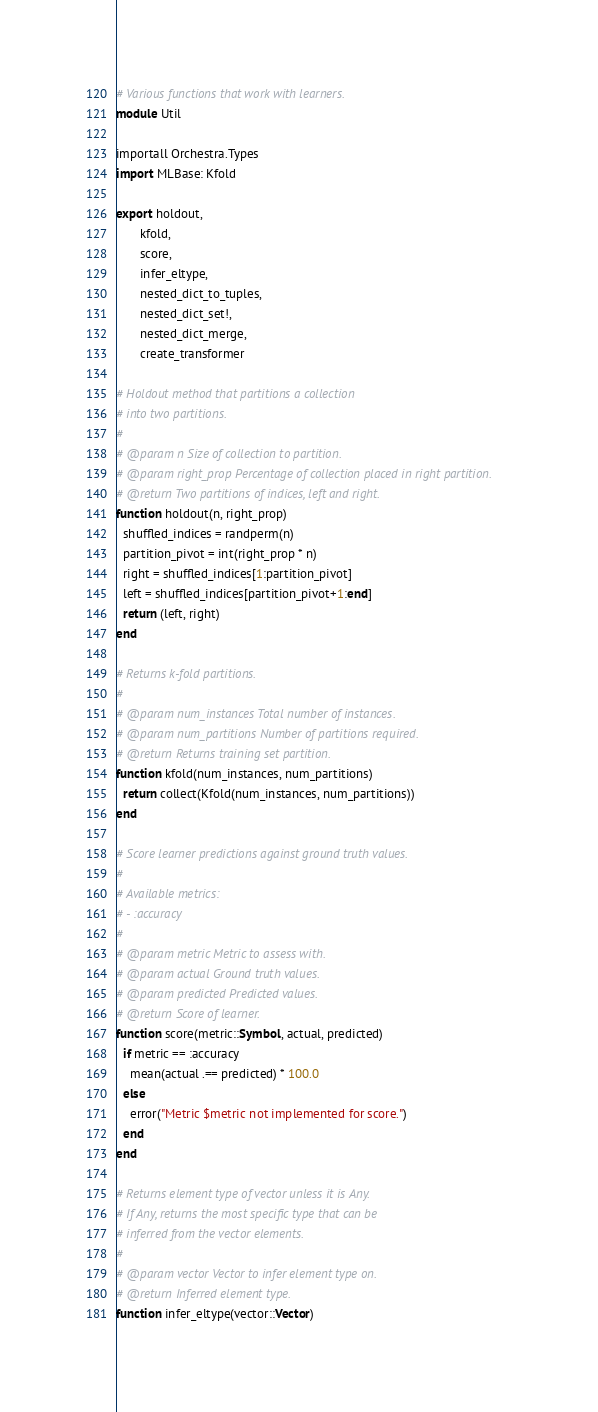<code> <loc_0><loc_0><loc_500><loc_500><_Julia_># Various functions that work with learners.
module Util

importall Orchestra.Types
import MLBase: Kfold

export holdout,
       kfold,
       score,
       infer_eltype,
       nested_dict_to_tuples,
       nested_dict_set!,
       nested_dict_merge,
       create_transformer

# Holdout method that partitions a collection
# into two partitions.
#
# @param n Size of collection to partition.
# @param right_prop Percentage of collection placed in right partition.
# @return Two partitions of indices, left and right.
function holdout(n, right_prop)
  shuffled_indices = randperm(n)
  partition_pivot = int(right_prop * n)
  right = shuffled_indices[1:partition_pivot]
  left = shuffled_indices[partition_pivot+1:end]
  return (left, right)
end

# Returns k-fold partitions.
#
# @param num_instances Total number of instances.
# @param num_partitions Number of partitions required.
# @return Returns training set partition.
function kfold(num_instances, num_partitions)
  return collect(Kfold(num_instances, num_partitions))
end

# Score learner predictions against ground truth values.
#
# Available metrics:
# - :accuracy
#
# @param metric Metric to assess with.
# @param actual Ground truth values.
# @param predicted Predicted values.
# @return Score of learner.
function score(metric::Symbol, actual, predicted)
  if metric == :accuracy
    mean(actual .== predicted) * 100.0
  else
    error("Metric $metric not implemented for score.")
  end
end

# Returns element type of vector unless it is Any.
# If Any, returns the most specific type that can be
# inferred from the vector elements.
#
# @param vector Vector to infer element type on.
# @return Inferred element type.
function infer_eltype(vector::Vector)</code> 